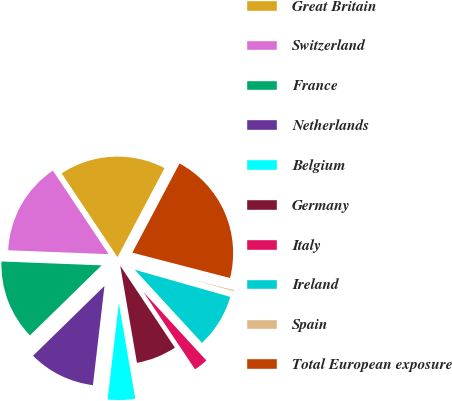<chart> <loc_0><loc_0><loc_500><loc_500><pie_chart><fcel>Great Britain<fcel>Switzerland<fcel>France<fcel>Netherlands<fcel>Belgium<fcel>Germany<fcel>Italy<fcel>Ireland<fcel>Spain<fcel>Total European exposure<nl><fcel>17.11%<fcel>15.02%<fcel>12.93%<fcel>10.84%<fcel>4.56%<fcel>6.65%<fcel>2.47%<fcel>8.75%<fcel>0.38%<fcel>21.29%<nl></chart> 